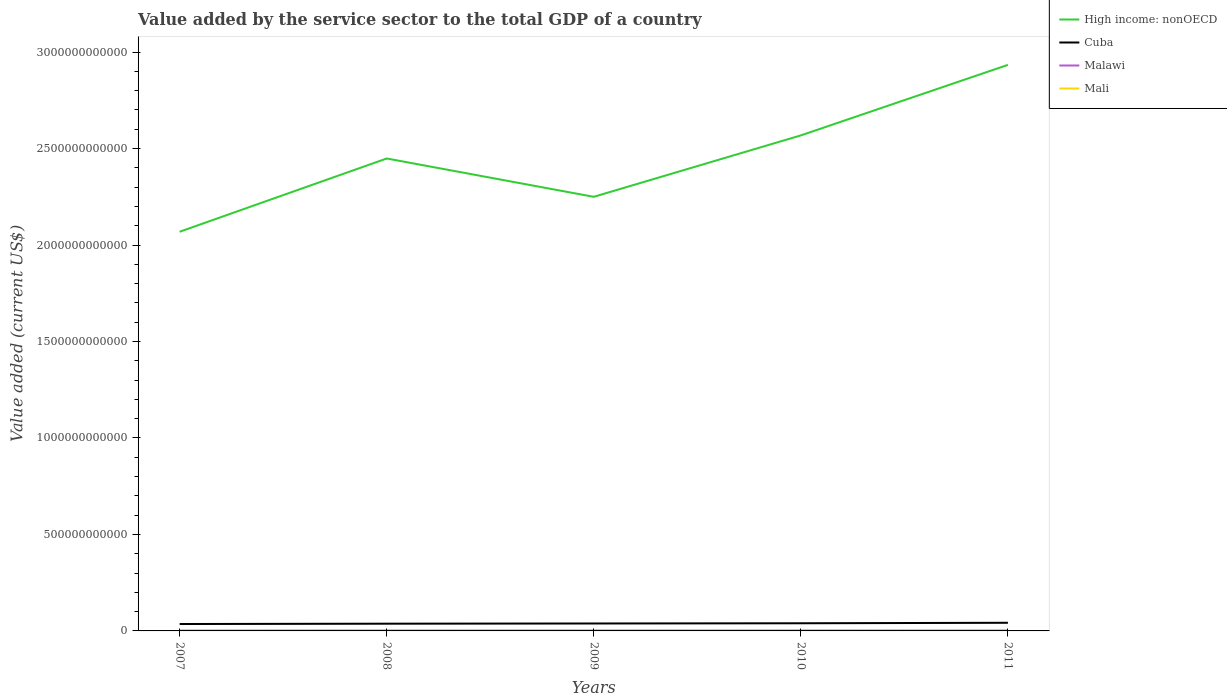How many different coloured lines are there?
Your response must be concise. 4. Does the line corresponding to Mali intersect with the line corresponding to Cuba?
Offer a very short reply. No. Is the number of lines equal to the number of legend labels?
Offer a terse response. Yes. Across all years, what is the maximum value added by the service sector to the total GDP in Malawi?
Make the answer very short. 1.69e+09. What is the total value added by the service sector to the total GDP in Cuba in the graph?
Provide a succinct answer. -1.09e+09. What is the difference between the highest and the second highest value added by the service sector to the total GDP in Cuba?
Offer a terse response. 6.36e+09. How many lines are there?
Your answer should be very brief. 4. How many years are there in the graph?
Your answer should be very brief. 5. What is the difference between two consecutive major ticks on the Y-axis?
Offer a very short reply. 5.00e+11. Does the graph contain any zero values?
Your response must be concise. No. How are the legend labels stacked?
Offer a very short reply. Vertical. What is the title of the graph?
Your response must be concise. Value added by the service sector to the total GDP of a country. What is the label or title of the X-axis?
Offer a very short reply. Years. What is the label or title of the Y-axis?
Provide a short and direct response. Value added (current US$). What is the Value added (current US$) of High income: nonOECD in 2007?
Offer a terse response. 2.07e+12. What is the Value added (current US$) in Cuba in 2007?
Offer a terse response. 3.58e+1. What is the Value added (current US$) of Malawi in 2007?
Provide a short and direct response. 1.69e+09. What is the Value added (current US$) of Mali in 2007?
Give a very brief answer. 2.64e+09. What is the Value added (current US$) in High income: nonOECD in 2008?
Your answer should be compact. 2.45e+12. What is the Value added (current US$) in Cuba in 2008?
Your answer should be compact. 3.75e+1. What is the Value added (current US$) of Malawi in 2008?
Your response must be concise. 2.08e+09. What is the Value added (current US$) in Mali in 2008?
Offer a terse response. 3.17e+09. What is the Value added (current US$) of High income: nonOECD in 2009?
Ensure brevity in your answer.  2.25e+12. What is the Value added (current US$) of Cuba in 2009?
Provide a short and direct response. 3.86e+1. What is the Value added (current US$) in Malawi in 2009?
Provide a succinct answer. 2.39e+09. What is the Value added (current US$) in Mali in 2009?
Your answer should be compact. 3.22e+09. What is the Value added (current US$) in High income: nonOECD in 2010?
Give a very brief answer. 2.57e+12. What is the Value added (current US$) in Cuba in 2010?
Offer a terse response. 3.97e+1. What is the Value added (current US$) in Malawi in 2010?
Your response must be concise. 2.54e+09. What is the Value added (current US$) in Mali in 2010?
Offer a terse response. 3.27e+09. What is the Value added (current US$) in High income: nonOECD in 2011?
Provide a succinct answer. 2.93e+12. What is the Value added (current US$) in Cuba in 2011?
Your answer should be very brief. 4.22e+1. What is the Value added (current US$) in Malawi in 2011?
Offer a very short reply. 2.56e+09. What is the Value added (current US$) in Mali in 2011?
Provide a succinct answer. 3.68e+09. Across all years, what is the maximum Value added (current US$) in High income: nonOECD?
Keep it short and to the point. 2.93e+12. Across all years, what is the maximum Value added (current US$) of Cuba?
Your answer should be compact. 4.22e+1. Across all years, what is the maximum Value added (current US$) of Malawi?
Make the answer very short. 2.56e+09. Across all years, what is the maximum Value added (current US$) of Mali?
Your answer should be very brief. 3.68e+09. Across all years, what is the minimum Value added (current US$) in High income: nonOECD?
Your answer should be very brief. 2.07e+12. Across all years, what is the minimum Value added (current US$) of Cuba?
Give a very brief answer. 3.58e+1. Across all years, what is the minimum Value added (current US$) in Malawi?
Offer a very short reply. 1.69e+09. Across all years, what is the minimum Value added (current US$) in Mali?
Provide a short and direct response. 2.64e+09. What is the total Value added (current US$) in High income: nonOECD in the graph?
Offer a very short reply. 1.23e+13. What is the total Value added (current US$) in Cuba in the graph?
Keep it short and to the point. 1.94e+11. What is the total Value added (current US$) in Malawi in the graph?
Provide a succinct answer. 1.13e+1. What is the total Value added (current US$) of Mali in the graph?
Offer a terse response. 1.60e+1. What is the difference between the Value added (current US$) of High income: nonOECD in 2007 and that in 2008?
Give a very brief answer. -3.80e+11. What is the difference between the Value added (current US$) of Cuba in 2007 and that in 2008?
Your answer should be compact. -1.69e+09. What is the difference between the Value added (current US$) in Malawi in 2007 and that in 2008?
Keep it short and to the point. -3.86e+08. What is the difference between the Value added (current US$) in Mali in 2007 and that in 2008?
Offer a very short reply. -5.26e+08. What is the difference between the Value added (current US$) in High income: nonOECD in 2007 and that in 2009?
Your answer should be compact. -1.81e+11. What is the difference between the Value added (current US$) in Cuba in 2007 and that in 2009?
Provide a succinct answer. -2.75e+09. What is the difference between the Value added (current US$) in Malawi in 2007 and that in 2009?
Provide a short and direct response. -6.97e+08. What is the difference between the Value added (current US$) in Mali in 2007 and that in 2009?
Provide a short and direct response. -5.83e+08. What is the difference between the Value added (current US$) of High income: nonOECD in 2007 and that in 2010?
Make the answer very short. -4.99e+11. What is the difference between the Value added (current US$) in Cuba in 2007 and that in 2010?
Keep it short and to the point. -3.84e+09. What is the difference between the Value added (current US$) of Malawi in 2007 and that in 2010?
Make the answer very short. -8.50e+08. What is the difference between the Value added (current US$) in Mali in 2007 and that in 2010?
Keep it short and to the point. -6.28e+08. What is the difference between the Value added (current US$) in High income: nonOECD in 2007 and that in 2011?
Your answer should be compact. -8.65e+11. What is the difference between the Value added (current US$) of Cuba in 2007 and that in 2011?
Ensure brevity in your answer.  -6.36e+09. What is the difference between the Value added (current US$) of Malawi in 2007 and that in 2011?
Make the answer very short. -8.66e+08. What is the difference between the Value added (current US$) of Mali in 2007 and that in 2011?
Provide a short and direct response. -1.04e+09. What is the difference between the Value added (current US$) of High income: nonOECD in 2008 and that in 2009?
Your response must be concise. 1.99e+11. What is the difference between the Value added (current US$) of Cuba in 2008 and that in 2009?
Provide a succinct answer. -1.06e+09. What is the difference between the Value added (current US$) in Malawi in 2008 and that in 2009?
Your answer should be compact. -3.12e+08. What is the difference between the Value added (current US$) of Mali in 2008 and that in 2009?
Your answer should be compact. -5.71e+07. What is the difference between the Value added (current US$) in High income: nonOECD in 2008 and that in 2010?
Your answer should be compact. -1.20e+11. What is the difference between the Value added (current US$) of Cuba in 2008 and that in 2010?
Provide a short and direct response. -2.15e+09. What is the difference between the Value added (current US$) in Malawi in 2008 and that in 2010?
Give a very brief answer. -4.65e+08. What is the difference between the Value added (current US$) of Mali in 2008 and that in 2010?
Your answer should be very brief. -1.02e+08. What is the difference between the Value added (current US$) in High income: nonOECD in 2008 and that in 2011?
Ensure brevity in your answer.  -4.85e+11. What is the difference between the Value added (current US$) of Cuba in 2008 and that in 2011?
Provide a succinct answer. -4.68e+09. What is the difference between the Value added (current US$) of Malawi in 2008 and that in 2011?
Provide a succinct answer. -4.81e+08. What is the difference between the Value added (current US$) in Mali in 2008 and that in 2011?
Keep it short and to the point. -5.11e+08. What is the difference between the Value added (current US$) of High income: nonOECD in 2009 and that in 2010?
Provide a succinct answer. -3.18e+11. What is the difference between the Value added (current US$) in Cuba in 2009 and that in 2010?
Make the answer very short. -1.09e+09. What is the difference between the Value added (current US$) in Malawi in 2009 and that in 2010?
Your answer should be compact. -1.53e+08. What is the difference between the Value added (current US$) in Mali in 2009 and that in 2010?
Give a very brief answer. -4.49e+07. What is the difference between the Value added (current US$) of High income: nonOECD in 2009 and that in 2011?
Your answer should be compact. -6.84e+11. What is the difference between the Value added (current US$) of Cuba in 2009 and that in 2011?
Make the answer very short. -3.61e+09. What is the difference between the Value added (current US$) of Malawi in 2009 and that in 2011?
Your answer should be compact. -1.69e+08. What is the difference between the Value added (current US$) in Mali in 2009 and that in 2011?
Your response must be concise. -4.54e+08. What is the difference between the Value added (current US$) in High income: nonOECD in 2010 and that in 2011?
Offer a very short reply. -3.66e+11. What is the difference between the Value added (current US$) in Cuba in 2010 and that in 2011?
Offer a terse response. -2.53e+09. What is the difference between the Value added (current US$) of Malawi in 2010 and that in 2011?
Your answer should be compact. -1.59e+07. What is the difference between the Value added (current US$) of Mali in 2010 and that in 2011?
Offer a very short reply. -4.09e+08. What is the difference between the Value added (current US$) in High income: nonOECD in 2007 and the Value added (current US$) in Cuba in 2008?
Offer a very short reply. 2.03e+12. What is the difference between the Value added (current US$) of High income: nonOECD in 2007 and the Value added (current US$) of Malawi in 2008?
Provide a short and direct response. 2.07e+12. What is the difference between the Value added (current US$) of High income: nonOECD in 2007 and the Value added (current US$) of Mali in 2008?
Provide a short and direct response. 2.07e+12. What is the difference between the Value added (current US$) of Cuba in 2007 and the Value added (current US$) of Malawi in 2008?
Offer a very short reply. 3.38e+1. What is the difference between the Value added (current US$) in Cuba in 2007 and the Value added (current US$) in Mali in 2008?
Your response must be concise. 3.27e+1. What is the difference between the Value added (current US$) in Malawi in 2007 and the Value added (current US$) in Mali in 2008?
Give a very brief answer. -1.47e+09. What is the difference between the Value added (current US$) of High income: nonOECD in 2007 and the Value added (current US$) of Cuba in 2009?
Keep it short and to the point. 2.03e+12. What is the difference between the Value added (current US$) in High income: nonOECD in 2007 and the Value added (current US$) in Malawi in 2009?
Your response must be concise. 2.07e+12. What is the difference between the Value added (current US$) of High income: nonOECD in 2007 and the Value added (current US$) of Mali in 2009?
Your answer should be very brief. 2.07e+12. What is the difference between the Value added (current US$) in Cuba in 2007 and the Value added (current US$) in Malawi in 2009?
Keep it short and to the point. 3.34e+1. What is the difference between the Value added (current US$) in Cuba in 2007 and the Value added (current US$) in Mali in 2009?
Offer a very short reply. 3.26e+1. What is the difference between the Value added (current US$) of Malawi in 2007 and the Value added (current US$) of Mali in 2009?
Keep it short and to the point. -1.53e+09. What is the difference between the Value added (current US$) of High income: nonOECD in 2007 and the Value added (current US$) of Cuba in 2010?
Give a very brief answer. 2.03e+12. What is the difference between the Value added (current US$) in High income: nonOECD in 2007 and the Value added (current US$) in Malawi in 2010?
Offer a terse response. 2.07e+12. What is the difference between the Value added (current US$) in High income: nonOECD in 2007 and the Value added (current US$) in Mali in 2010?
Offer a very short reply. 2.07e+12. What is the difference between the Value added (current US$) in Cuba in 2007 and the Value added (current US$) in Malawi in 2010?
Provide a succinct answer. 3.33e+1. What is the difference between the Value added (current US$) in Cuba in 2007 and the Value added (current US$) in Mali in 2010?
Keep it short and to the point. 3.26e+1. What is the difference between the Value added (current US$) of Malawi in 2007 and the Value added (current US$) of Mali in 2010?
Provide a succinct answer. -1.57e+09. What is the difference between the Value added (current US$) in High income: nonOECD in 2007 and the Value added (current US$) in Cuba in 2011?
Give a very brief answer. 2.03e+12. What is the difference between the Value added (current US$) in High income: nonOECD in 2007 and the Value added (current US$) in Malawi in 2011?
Keep it short and to the point. 2.07e+12. What is the difference between the Value added (current US$) in High income: nonOECD in 2007 and the Value added (current US$) in Mali in 2011?
Your answer should be compact. 2.07e+12. What is the difference between the Value added (current US$) of Cuba in 2007 and the Value added (current US$) of Malawi in 2011?
Give a very brief answer. 3.33e+1. What is the difference between the Value added (current US$) in Cuba in 2007 and the Value added (current US$) in Mali in 2011?
Provide a short and direct response. 3.22e+1. What is the difference between the Value added (current US$) in Malawi in 2007 and the Value added (current US$) in Mali in 2011?
Offer a very short reply. -1.98e+09. What is the difference between the Value added (current US$) in High income: nonOECD in 2008 and the Value added (current US$) in Cuba in 2009?
Your answer should be very brief. 2.41e+12. What is the difference between the Value added (current US$) in High income: nonOECD in 2008 and the Value added (current US$) in Malawi in 2009?
Make the answer very short. 2.45e+12. What is the difference between the Value added (current US$) of High income: nonOECD in 2008 and the Value added (current US$) of Mali in 2009?
Your answer should be very brief. 2.45e+12. What is the difference between the Value added (current US$) of Cuba in 2008 and the Value added (current US$) of Malawi in 2009?
Your answer should be very brief. 3.51e+1. What is the difference between the Value added (current US$) of Cuba in 2008 and the Value added (current US$) of Mali in 2009?
Offer a very short reply. 3.43e+1. What is the difference between the Value added (current US$) of Malawi in 2008 and the Value added (current US$) of Mali in 2009?
Provide a succinct answer. -1.14e+09. What is the difference between the Value added (current US$) of High income: nonOECD in 2008 and the Value added (current US$) of Cuba in 2010?
Keep it short and to the point. 2.41e+12. What is the difference between the Value added (current US$) in High income: nonOECD in 2008 and the Value added (current US$) in Malawi in 2010?
Your answer should be very brief. 2.45e+12. What is the difference between the Value added (current US$) in High income: nonOECD in 2008 and the Value added (current US$) in Mali in 2010?
Your answer should be very brief. 2.45e+12. What is the difference between the Value added (current US$) in Cuba in 2008 and the Value added (current US$) in Malawi in 2010?
Make the answer very short. 3.50e+1. What is the difference between the Value added (current US$) of Cuba in 2008 and the Value added (current US$) of Mali in 2010?
Your answer should be very brief. 3.43e+1. What is the difference between the Value added (current US$) in Malawi in 2008 and the Value added (current US$) in Mali in 2010?
Keep it short and to the point. -1.19e+09. What is the difference between the Value added (current US$) of High income: nonOECD in 2008 and the Value added (current US$) of Cuba in 2011?
Provide a succinct answer. 2.41e+12. What is the difference between the Value added (current US$) in High income: nonOECD in 2008 and the Value added (current US$) in Malawi in 2011?
Offer a terse response. 2.45e+12. What is the difference between the Value added (current US$) in High income: nonOECD in 2008 and the Value added (current US$) in Mali in 2011?
Offer a terse response. 2.44e+12. What is the difference between the Value added (current US$) of Cuba in 2008 and the Value added (current US$) of Malawi in 2011?
Make the answer very short. 3.50e+1. What is the difference between the Value added (current US$) of Cuba in 2008 and the Value added (current US$) of Mali in 2011?
Keep it short and to the point. 3.38e+1. What is the difference between the Value added (current US$) in Malawi in 2008 and the Value added (current US$) in Mali in 2011?
Offer a very short reply. -1.60e+09. What is the difference between the Value added (current US$) of High income: nonOECD in 2009 and the Value added (current US$) of Cuba in 2010?
Provide a succinct answer. 2.21e+12. What is the difference between the Value added (current US$) of High income: nonOECD in 2009 and the Value added (current US$) of Malawi in 2010?
Offer a very short reply. 2.25e+12. What is the difference between the Value added (current US$) in High income: nonOECD in 2009 and the Value added (current US$) in Mali in 2010?
Make the answer very short. 2.25e+12. What is the difference between the Value added (current US$) in Cuba in 2009 and the Value added (current US$) in Malawi in 2010?
Offer a very short reply. 3.60e+1. What is the difference between the Value added (current US$) in Cuba in 2009 and the Value added (current US$) in Mali in 2010?
Your response must be concise. 3.53e+1. What is the difference between the Value added (current US$) in Malawi in 2009 and the Value added (current US$) in Mali in 2010?
Offer a terse response. -8.76e+08. What is the difference between the Value added (current US$) in High income: nonOECD in 2009 and the Value added (current US$) in Cuba in 2011?
Offer a very short reply. 2.21e+12. What is the difference between the Value added (current US$) of High income: nonOECD in 2009 and the Value added (current US$) of Malawi in 2011?
Keep it short and to the point. 2.25e+12. What is the difference between the Value added (current US$) in High income: nonOECD in 2009 and the Value added (current US$) in Mali in 2011?
Offer a very short reply. 2.25e+12. What is the difference between the Value added (current US$) in Cuba in 2009 and the Value added (current US$) in Malawi in 2011?
Provide a short and direct response. 3.60e+1. What is the difference between the Value added (current US$) of Cuba in 2009 and the Value added (current US$) of Mali in 2011?
Your answer should be very brief. 3.49e+1. What is the difference between the Value added (current US$) in Malawi in 2009 and the Value added (current US$) in Mali in 2011?
Ensure brevity in your answer.  -1.29e+09. What is the difference between the Value added (current US$) in High income: nonOECD in 2010 and the Value added (current US$) in Cuba in 2011?
Keep it short and to the point. 2.53e+12. What is the difference between the Value added (current US$) of High income: nonOECD in 2010 and the Value added (current US$) of Malawi in 2011?
Give a very brief answer. 2.57e+12. What is the difference between the Value added (current US$) in High income: nonOECD in 2010 and the Value added (current US$) in Mali in 2011?
Offer a very short reply. 2.56e+12. What is the difference between the Value added (current US$) of Cuba in 2010 and the Value added (current US$) of Malawi in 2011?
Your answer should be very brief. 3.71e+1. What is the difference between the Value added (current US$) of Cuba in 2010 and the Value added (current US$) of Mali in 2011?
Ensure brevity in your answer.  3.60e+1. What is the difference between the Value added (current US$) in Malawi in 2010 and the Value added (current US$) in Mali in 2011?
Offer a very short reply. -1.13e+09. What is the average Value added (current US$) of High income: nonOECD per year?
Provide a short and direct response. 2.45e+12. What is the average Value added (current US$) in Cuba per year?
Offer a very short reply. 3.88e+1. What is the average Value added (current US$) of Malawi per year?
Keep it short and to the point. 2.25e+09. What is the average Value added (current US$) in Mali per year?
Your answer should be very brief. 3.19e+09. In the year 2007, what is the difference between the Value added (current US$) of High income: nonOECD and Value added (current US$) of Cuba?
Ensure brevity in your answer.  2.03e+12. In the year 2007, what is the difference between the Value added (current US$) of High income: nonOECD and Value added (current US$) of Malawi?
Provide a succinct answer. 2.07e+12. In the year 2007, what is the difference between the Value added (current US$) in High income: nonOECD and Value added (current US$) in Mali?
Keep it short and to the point. 2.07e+12. In the year 2007, what is the difference between the Value added (current US$) of Cuba and Value added (current US$) of Malawi?
Keep it short and to the point. 3.41e+1. In the year 2007, what is the difference between the Value added (current US$) in Cuba and Value added (current US$) in Mali?
Offer a very short reply. 3.32e+1. In the year 2007, what is the difference between the Value added (current US$) in Malawi and Value added (current US$) in Mali?
Offer a very short reply. -9.46e+08. In the year 2008, what is the difference between the Value added (current US$) of High income: nonOECD and Value added (current US$) of Cuba?
Make the answer very short. 2.41e+12. In the year 2008, what is the difference between the Value added (current US$) in High income: nonOECD and Value added (current US$) in Malawi?
Offer a very short reply. 2.45e+12. In the year 2008, what is the difference between the Value added (current US$) of High income: nonOECD and Value added (current US$) of Mali?
Give a very brief answer. 2.45e+12. In the year 2008, what is the difference between the Value added (current US$) in Cuba and Value added (current US$) in Malawi?
Ensure brevity in your answer.  3.54e+1. In the year 2008, what is the difference between the Value added (current US$) in Cuba and Value added (current US$) in Mali?
Provide a short and direct response. 3.44e+1. In the year 2008, what is the difference between the Value added (current US$) of Malawi and Value added (current US$) of Mali?
Make the answer very short. -1.09e+09. In the year 2009, what is the difference between the Value added (current US$) in High income: nonOECD and Value added (current US$) in Cuba?
Offer a terse response. 2.21e+12. In the year 2009, what is the difference between the Value added (current US$) in High income: nonOECD and Value added (current US$) in Malawi?
Provide a succinct answer. 2.25e+12. In the year 2009, what is the difference between the Value added (current US$) in High income: nonOECD and Value added (current US$) in Mali?
Make the answer very short. 2.25e+12. In the year 2009, what is the difference between the Value added (current US$) in Cuba and Value added (current US$) in Malawi?
Provide a short and direct response. 3.62e+1. In the year 2009, what is the difference between the Value added (current US$) of Cuba and Value added (current US$) of Mali?
Give a very brief answer. 3.54e+1. In the year 2009, what is the difference between the Value added (current US$) in Malawi and Value added (current US$) in Mali?
Provide a short and direct response. -8.32e+08. In the year 2010, what is the difference between the Value added (current US$) of High income: nonOECD and Value added (current US$) of Cuba?
Offer a very short reply. 2.53e+12. In the year 2010, what is the difference between the Value added (current US$) of High income: nonOECD and Value added (current US$) of Malawi?
Provide a short and direct response. 2.57e+12. In the year 2010, what is the difference between the Value added (current US$) in High income: nonOECD and Value added (current US$) in Mali?
Offer a terse response. 2.56e+12. In the year 2010, what is the difference between the Value added (current US$) in Cuba and Value added (current US$) in Malawi?
Your answer should be very brief. 3.71e+1. In the year 2010, what is the difference between the Value added (current US$) of Cuba and Value added (current US$) of Mali?
Make the answer very short. 3.64e+1. In the year 2010, what is the difference between the Value added (current US$) of Malawi and Value added (current US$) of Mali?
Ensure brevity in your answer.  -7.23e+08. In the year 2011, what is the difference between the Value added (current US$) of High income: nonOECD and Value added (current US$) of Cuba?
Your answer should be compact. 2.89e+12. In the year 2011, what is the difference between the Value added (current US$) of High income: nonOECD and Value added (current US$) of Malawi?
Provide a succinct answer. 2.93e+12. In the year 2011, what is the difference between the Value added (current US$) of High income: nonOECD and Value added (current US$) of Mali?
Your response must be concise. 2.93e+12. In the year 2011, what is the difference between the Value added (current US$) in Cuba and Value added (current US$) in Malawi?
Make the answer very short. 3.96e+1. In the year 2011, what is the difference between the Value added (current US$) in Cuba and Value added (current US$) in Mali?
Your answer should be very brief. 3.85e+1. In the year 2011, what is the difference between the Value added (current US$) in Malawi and Value added (current US$) in Mali?
Your answer should be very brief. -1.12e+09. What is the ratio of the Value added (current US$) of High income: nonOECD in 2007 to that in 2008?
Offer a very short reply. 0.84. What is the ratio of the Value added (current US$) in Cuba in 2007 to that in 2008?
Give a very brief answer. 0.95. What is the ratio of the Value added (current US$) of Malawi in 2007 to that in 2008?
Your answer should be compact. 0.81. What is the ratio of the Value added (current US$) in Mali in 2007 to that in 2008?
Your answer should be compact. 0.83. What is the ratio of the Value added (current US$) of High income: nonOECD in 2007 to that in 2009?
Your answer should be very brief. 0.92. What is the ratio of the Value added (current US$) of Cuba in 2007 to that in 2009?
Offer a very short reply. 0.93. What is the ratio of the Value added (current US$) of Malawi in 2007 to that in 2009?
Your response must be concise. 0.71. What is the ratio of the Value added (current US$) in Mali in 2007 to that in 2009?
Provide a short and direct response. 0.82. What is the ratio of the Value added (current US$) of High income: nonOECD in 2007 to that in 2010?
Keep it short and to the point. 0.81. What is the ratio of the Value added (current US$) in Cuba in 2007 to that in 2010?
Offer a terse response. 0.9. What is the ratio of the Value added (current US$) of Malawi in 2007 to that in 2010?
Your response must be concise. 0.67. What is the ratio of the Value added (current US$) in Mali in 2007 to that in 2010?
Keep it short and to the point. 0.81. What is the ratio of the Value added (current US$) in High income: nonOECD in 2007 to that in 2011?
Provide a short and direct response. 0.71. What is the ratio of the Value added (current US$) of Cuba in 2007 to that in 2011?
Your answer should be compact. 0.85. What is the ratio of the Value added (current US$) in Malawi in 2007 to that in 2011?
Offer a very short reply. 0.66. What is the ratio of the Value added (current US$) of Mali in 2007 to that in 2011?
Give a very brief answer. 0.72. What is the ratio of the Value added (current US$) of High income: nonOECD in 2008 to that in 2009?
Give a very brief answer. 1.09. What is the ratio of the Value added (current US$) of Cuba in 2008 to that in 2009?
Give a very brief answer. 0.97. What is the ratio of the Value added (current US$) of Malawi in 2008 to that in 2009?
Give a very brief answer. 0.87. What is the ratio of the Value added (current US$) in Mali in 2008 to that in 2009?
Your answer should be compact. 0.98. What is the ratio of the Value added (current US$) in High income: nonOECD in 2008 to that in 2010?
Your response must be concise. 0.95. What is the ratio of the Value added (current US$) of Cuba in 2008 to that in 2010?
Offer a very short reply. 0.95. What is the ratio of the Value added (current US$) in Malawi in 2008 to that in 2010?
Provide a short and direct response. 0.82. What is the ratio of the Value added (current US$) of Mali in 2008 to that in 2010?
Give a very brief answer. 0.97. What is the ratio of the Value added (current US$) of High income: nonOECD in 2008 to that in 2011?
Give a very brief answer. 0.83. What is the ratio of the Value added (current US$) in Cuba in 2008 to that in 2011?
Offer a very short reply. 0.89. What is the ratio of the Value added (current US$) of Malawi in 2008 to that in 2011?
Your response must be concise. 0.81. What is the ratio of the Value added (current US$) of Mali in 2008 to that in 2011?
Your answer should be compact. 0.86. What is the ratio of the Value added (current US$) of High income: nonOECD in 2009 to that in 2010?
Offer a terse response. 0.88. What is the ratio of the Value added (current US$) of Cuba in 2009 to that in 2010?
Give a very brief answer. 0.97. What is the ratio of the Value added (current US$) in Malawi in 2009 to that in 2010?
Provide a short and direct response. 0.94. What is the ratio of the Value added (current US$) in Mali in 2009 to that in 2010?
Ensure brevity in your answer.  0.99. What is the ratio of the Value added (current US$) of High income: nonOECD in 2009 to that in 2011?
Your answer should be compact. 0.77. What is the ratio of the Value added (current US$) in Cuba in 2009 to that in 2011?
Provide a succinct answer. 0.91. What is the ratio of the Value added (current US$) in Malawi in 2009 to that in 2011?
Provide a succinct answer. 0.93. What is the ratio of the Value added (current US$) in Mali in 2009 to that in 2011?
Provide a succinct answer. 0.88. What is the ratio of the Value added (current US$) in High income: nonOECD in 2010 to that in 2011?
Offer a terse response. 0.88. What is the ratio of the Value added (current US$) of Cuba in 2010 to that in 2011?
Make the answer very short. 0.94. What is the ratio of the Value added (current US$) in Mali in 2010 to that in 2011?
Offer a terse response. 0.89. What is the difference between the highest and the second highest Value added (current US$) of High income: nonOECD?
Provide a short and direct response. 3.66e+11. What is the difference between the highest and the second highest Value added (current US$) of Cuba?
Keep it short and to the point. 2.53e+09. What is the difference between the highest and the second highest Value added (current US$) of Malawi?
Your response must be concise. 1.59e+07. What is the difference between the highest and the second highest Value added (current US$) in Mali?
Your answer should be compact. 4.09e+08. What is the difference between the highest and the lowest Value added (current US$) of High income: nonOECD?
Make the answer very short. 8.65e+11. What is the difference between the highest and the lowest Value added (current US$) of Cuba?
Offer a terse response. 6.36e+09. What is the difference between the highest and the lowest Value added (current US$) of Malawi?
Keep it short and to the point. 8.66e+08. What is the difference between the highest and the lowest Value added (current US$) in Mali?
Your answer should be very brief. 1.04e+09. 